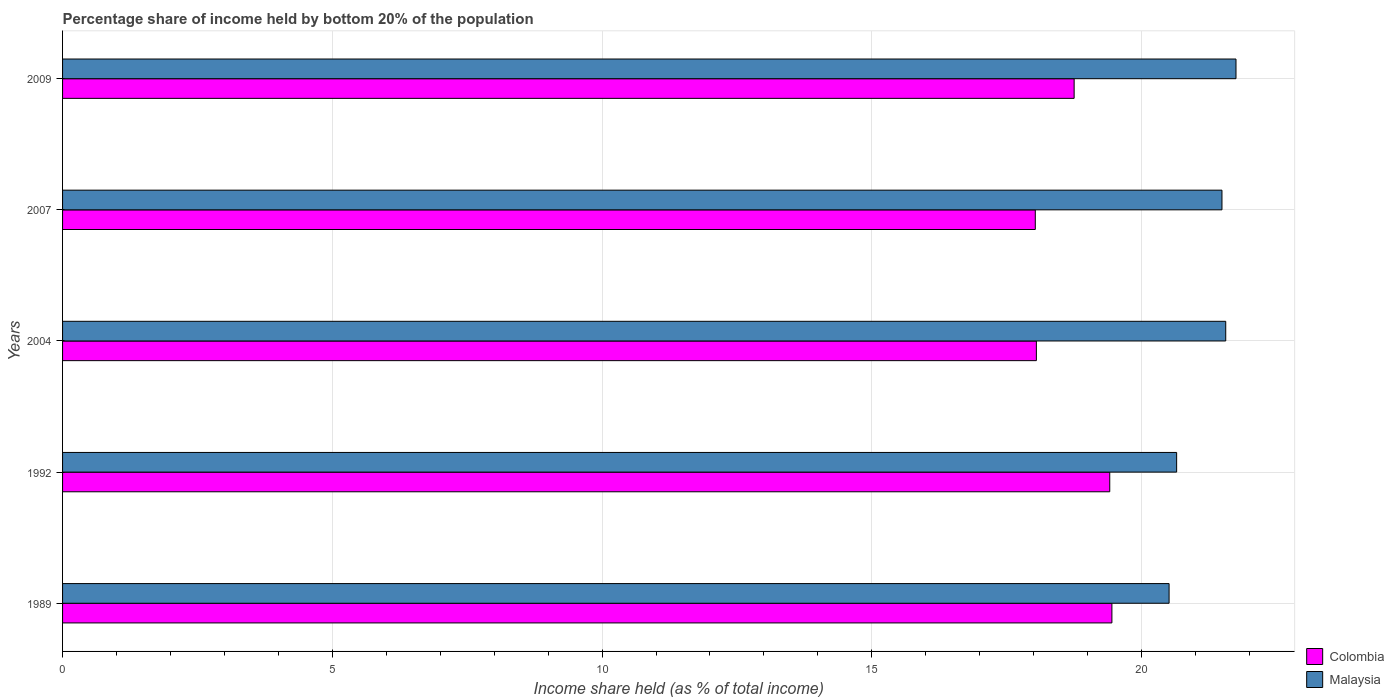Are the number of bars per tick equal to the number of legend labels?
Make the answer very short. Yes. Are the number of bars on each tick of the Y-axis equal?
Provide a succinct answer. Yes. How many bars are there on the 2nd tick from the bottom?
Ensure brevity in your answer.  2. What is the share of income held by bottom 20% of the population in Colombia in 1992?
Your answer should be compact. 19.41. Across all years, what is the maximum share of income held by bottom 20% of the population in Colombia?
Offer a very short reply. 19.45. Across all years, what is the minimum share of income held by bottom 20% of the population in Colombia?
Give a very brief answer. 18.03. In which year was the share of income held by bottom 20% of the population in Colombia maximum?
Provide a succinct answer. 1989. What is the total share of income held by bottom 20% of the population in Colombia in the graph?
Provide a short and direct response. 93.69. What is the difference between the share of income held by bottom 20% of the population in Colombia in 1989 and that in 2009?
Keep it short and to the point. 0.7. What is the difference between the share of income held by bottom 20% of the population in Malaysia in 1992 and the share of income held by bottom 20% of the population in Colombia in 2007?
Give a very brief answer. 2.62. What is the average share of income held by bottom 20% of the population in Colombia per year?
Your answer should be compact. 18.74. In the year 2004, what is the difference between the share of income held by bottom 20% of the population in Colombia and share of income held by bottom 20% of the population in Malaysia?
Offer a terse response. -3.51. In how many years, is the share of income held by bottom 20% of the population in Malaysia greater than 16 %?
Your response must be concise. 5. What is the ratio of the share of income held by bottom 20% of the population in Malaysia in 1992 to that in 2004?
Give a very brief answer. 0.96. Is the share of income held by bottom 20% of the population in Colombia in 1989 less than that in 2007?
Provide a succinct answer. No. Is the difference between the share of income held by bottom 20% of the population in Colombia in 2007 and 2009 greater than the difference between the share of income held by bottom 20% of the population in Malaysia in 2007 and 2009?
Ensure brevity in your answer.  No. What is the difference between the highest and the second highest share of income held by bottom 20% of the population in Colombia?
Give a very brief answer. 0.04. What is the difference between the highest and the lowest share of income held by bottom 20% of the population in Colombia?
Provide a short and direct response. 1.42. In how many years, is the share of income held by bottom 20% of the population in Malaysia greater than the average share of income held by bottom 20% of the population in Malaysia taken over all years?
Offer a terse response. 3. What does the 1st bar from the top in 1989 represents?
Your response must be concise. Malaysia. What does the 2nd bar from the bottom in 2004 represents?
Provide a short and direct response. Malaysia. Are the values on the major ticks of X-axis written in scientific E-notation?
Your response must be concise. No. Does the graph contain grids?
Provide a succinct answer. Yes. How many legend labels are there?
Offer a very short reply. 2. How are the legend labels stacked?
Give a very brief answer. Vertical. What is the title of the graph?
Your answer should be compact. Percentage share of income held by bottom 20% of the population. Does "Liberia" appear as one of the legend labels in the graph?
Your answer should be very brief. No. What is the label or title of the X-axis?
Offer a terse response. Income share held (as % of total income). What is the label or title of the Y-axis?
Offer a terse response. Years. What is the Income share held (as % of total income) of Colombia in 1989?
Offer a very short reply. 19.45. What is the Income share held (as % of total income) of Malaysia in 1989?
Keep it short and to the point. 20.51. What is the Income share held (as % of total income) of Colombia in 1992?
Your response must be concise. 19.41. What is the Income share held (as % of total income) in Malaysia in 1992?
Your answer should be very brief. 20.65. What is the Income share held (as % of total income) in Colombia in 2004?
Make the answer very short. 18.05. What is the Income share held (as % of total income) of Malaysia in 2004?
Provide a short and direct response. 21.56. What is the Income share held (as % of total income) of Colombia in 2007?
Ensure brevity in your answer.  18.03. What is the Income share held (as % of total income) of Malaysia in 2007?
Give a very brief answer. 21.49. What is the Income share held (as % of total income) of Colombia in 2009?
Provide a succinct answer. 18.75. What is the Income share held (as % of total income) in Malaysia in 2009?
Ensure brevity in your answer.  21.75. Across all years, what is the maximum Income share held (as % of total income) of Colombia?
Offer a terse response. 19.45. Across all years, what is the maximum Income share held (as % of total income) in Malaysia?
Provide a succinct answer. 21.75. Across all years, what is the minimum Income share held (as % of total income) of Colombia?
Your answer should be very brief. 18.03. Across all years, what is the minimum Income share held (as % of total income) of Malaysia?
Provide a short and direct response. 20.51. What is the total Income share held (as % of total income) in Colombia in the graph?
Ensure brevity in your answer.  93.69. What is the total Income share held (as % of total income) in Malaysia in the graph?
Make the answer very short. 105.96. What is the difference between the Income share held (as % of total income) of Colombia in 1989 and that in 1992?
Give a very brief answer. 0.04. What is the difference between the Income share held (as % of total income) of Malaysia in 1989 and that in 1992?
Keep it short and to the point. -0.14. What is the difference between the Income share held (as % of total income) in Malaysia in 1989 and that in 2004?
Offer a terse response. -1.05. What is the difference between the Income share held (as % of total income) of Colombia in 1989 and that in 2007?
Ensure brevity in your answer.  1.42. What is the difference between the Income share held (as % of total income) in Malaysia in 1989 and that in 2007?
Offer a terse response. -0.98. What is the difference between the Income share held (as % of total income) of Colombia in 1989 and that in 2009?
Provide a succinct answer. 0.7. What is the difference between the Income share held (as % of total income) in Malaysia in 1989 and that in 2009?
Provide a succinct answer. -1.24. What is the difference between the Income share held (as % of total income) of Colombia in 1992 and that in 2004?
Provide a succinct answer. 1.36. What is the difference between the Income share held (as % of total income) of Malaysia in 1992 and that in 2004?
Your response must be concise. -0.91. What is the difference between the Income share held (as % of total income) of Colombia in 1992 and that in 2007?
Keep it short and to the point. 1.38. What is the difference between the Income share held (as % of total income) in Malaysia in 1992 and that in 2007?
Give a very brief answer. -0.84. What is the difference between the Income share held (as % of total income) of Colombia in 1992 and that in 2009?
Keep it short and to the point. 0.66. What is the difference between the Income share held (as % of total income) in Malaysia in 1992 and that in 2009?
Provide a succinct answer. -1.1. What is the difference between the Income share held (as % of total income) in Colombia in 2004 and that in 2007?
Your response must be concise. 0.02. What is the difference between the Income share held (as % of total income) in Malaysia in 2004 and that in 2007?
Offer a very short reply. 0.07. What is the difference between the Income share held (as % of total income) in Colombia in 2004 and that in 2009?
Provide a short and direct response. -0.7. What is the difference between the Income share held (as % of total income) of Malaysia in 2004 and that in 2009?
Your response must be concise. -0.19. What is the difference between the Income share held (as % of total income) of Colombia in 2007 and that in 2009?
Offer a very short reply. -0.72. What is the difference between the Income share held (as % of total income) of Malaysia in 2007 and that in 2009?
Your response must be concise. -0.26. What is the difference between the Income share held (as % of total income) of Colombia in 1989 and the Income share held (as % of total income) of Malaysia in 1992?
Your answer should be compact. -1.2. What is the difference between the Income share held (as % of total income) in Colombia in 1989 and the Income share held (as % of total income) in Malaysia in 2004?
Make the answer very short. -2.11. What is the difference between the Income share held (as % of total income) in Colombia in 1989 and the Income share held (as % of total income) in Malaysia in 2007?
Offer a very short reply. -2.04. What is the difference between the Income share held (as % of total income) in Colombia in 1992 and the Income share held (as % of total income) in Malaysia in 2004?
Your response must be concise. -2.15. What is the difference between the Income share held (as % of total income) of Colombia in 1992 and the Income share held (as % of total income) of Malaysia in 2007?
Keep it short and to the point. -2.08. What is the difference between the Income share held (as % of total income) of Colombia in 1992 and the Income share held (as % of total income) of Malaysia in 2009?
Offer a very short reply. -2.34. What is the difference between the Income share held (as % of total income) of Colombia in 2004 and the Income share held (as % of total income) of Malaysia in 2007?
Ensure brevity in your answer.  -3.44. What is the difference between the Income share held (as % of total income) in Colombia in 2004 and the Income share held (as % of total income) in Malaysia in 2009?
Make the answer very short. -3.7. What is the difference between the Income share held (as % of total income) in Colombia in 2007 and the Income share held (as % of total income) in Malaysia in 2009?
Offer a very short reply. -3.72. What is the average Income share held (as % of total income) of Colombia per year?
Keep it short and to the point. 18.74. What is the average Income share held (as % of total income) of Malaysia per year?
Your response must be concise. 21.19. In the year 1989, what is the difference between the Income share held (as % of total income) of Colombia and Income share held (as % of total income) of Malaysia?
Ensure brevity in your answer.  -1.06. In the year 1992, what is the difference between the Income share held (as % of total income) of Colombia and Income share held (as % of total income) of Malaysia?
Offer a terse response. -1.24. In the year 2004, what is the difference between the Income share held (as % of total income) of Colombia and Income share held (as % of total income) of Malaysia?
Your response must be concise. -3.51. In the year 2007, what is the difference between the Income share held (as % of total income) in Colombia and Income share held (as % of total income) in Malaysia?
Ensure brevity in your answer.  -3.46. In the year 2009, what is the difference between the Income share held (as % of total income) in Colombia and Income share held (as % of total income) in Malaysia?
Provide a short and direct response. -3. What is the ratio of the Income share held (as % of total income) in Colombia in 1989 to that in 1992?
Make the answer very short. 1. What is the ratio of the Income share held (as % of total income) of Malaysia in 1989 to that in 1992?
Your answer should be compact. 0.99. What is the ratio of the Income share held (as % of total income) in Colombia in 1989 to that in 2004?
Keep it short and to the point. 1.08. What is the ratio of the Income share held (as % of total income) of Malaysia in 1989 to that in 2004?
Your response must be concise. 0.95. What is the ratio of the Income share held (as % of total income) in Colombia in 1989 to that in 2007?
Ensure brevity in your answer.  1.08. What is the ratio of the Income share held (as % of total income) in Malaysia in 1989 to that in 2007?
Give a very brief answer. 0.95. What is the ratio of the Income share held (as % of total income) of Colombia in 1989 to that in 2009?
Your response must be concise. 1.04. What is the ratio of the Income share held (as % of total income) of Malaysia in 1989 to that in 2009?
Your response must be concise. 0.94. What is the ratio of the Income share held (as % of total income) of Colombia in 1992 to that in 2004?
Offer a very short reply. 1.08. What is the ratio of the Income share held (as % of total income) in Malaysia in 1992 to that in 2004?
Offer a terse response. 0.96. What is the ratio of the Income share held (as % of total income) of Colombia in 1992 to that in 2007?
Your answer should be very brief. 1.08. What is the ratio of the Income share held (as % of total income) of Malaysia in 1992 to that in 2007?
Offer a very short reply. 0.96. What is the ratio of the Income share held (as % of total income) in Colombia in 1992 to that in 2009?
Your answer should be very brief. 1.04. What is the ratio of the Income share held (as % of total income) in Malaysia in 1992 to that in 2009?
Provide a succinct answer. 0.95. What is the ratio of the Income share held (as % of total income) in Colombia in 2004 to that in 2007?
Your answer should be very brief. 1. What is the ratio of the Income share held (as % of total income) of Colombia in 2004 to that in 2009?
Offer a very short reply. 0.96. What is the ratio of the Income share held (as % of total income) of Malaysia in 2004 to that in 2009?
Keep it short and to the point. 0.99. What is the ratio of the Income share held (as % of total income) of Colombia in 2007 to that in 2009?
Offer a very short reply. 0.96. What is the difference between the highest and the second highest Income share held (as % of total income) of Malaysia?
Provide a succinct answer. 0.19. What is the difference between the highest and the lowest Income share held (as % of total income) in Colombia?
Give a very brief answer. 1.42. What is the difference between the highest and the lowest Income share held (as % of total income) in Malaysia?
Offer a terse response. 1.24. 